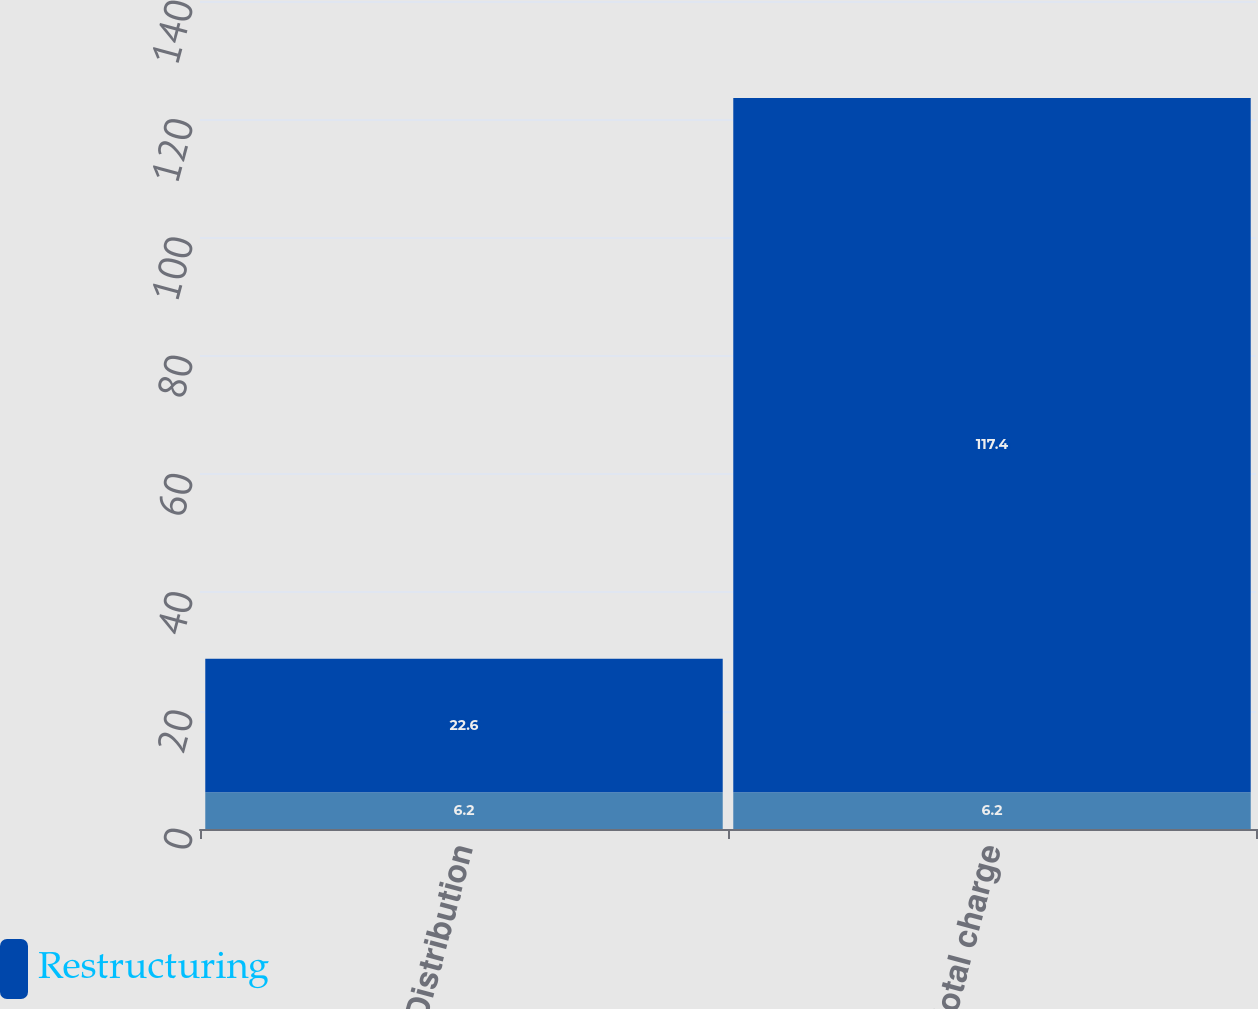Convert chart. <chart><loc_0><loc_0><loc_500><loc_500><stacked_bar_chart><ecel><fcel>Distribution<fcel>Total charge<nl><fcel>nan<fcel>6.2<fcel>6.2<nl><fcel>Restructuring<fcel>22.6<fcel>117.4<nl></chart> 